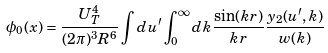Convert formula to latex. <formula><loc_0><loc_0><loc_500><loc_500>\phi _ { 0 } ( x ) = \frac { U _ { T } ^ { 4 } } { ( 2 \pi ) ^ { 3 } R ^ { 6 } } \int d u ^ { \prime } \int _ { 0 } ^ { \infty } d k \frac { \sin ( k r ) } { k r } \frac { y _ { 2 } ( u ^ { \prime } , k ) } { w ( k ) }</formula> 